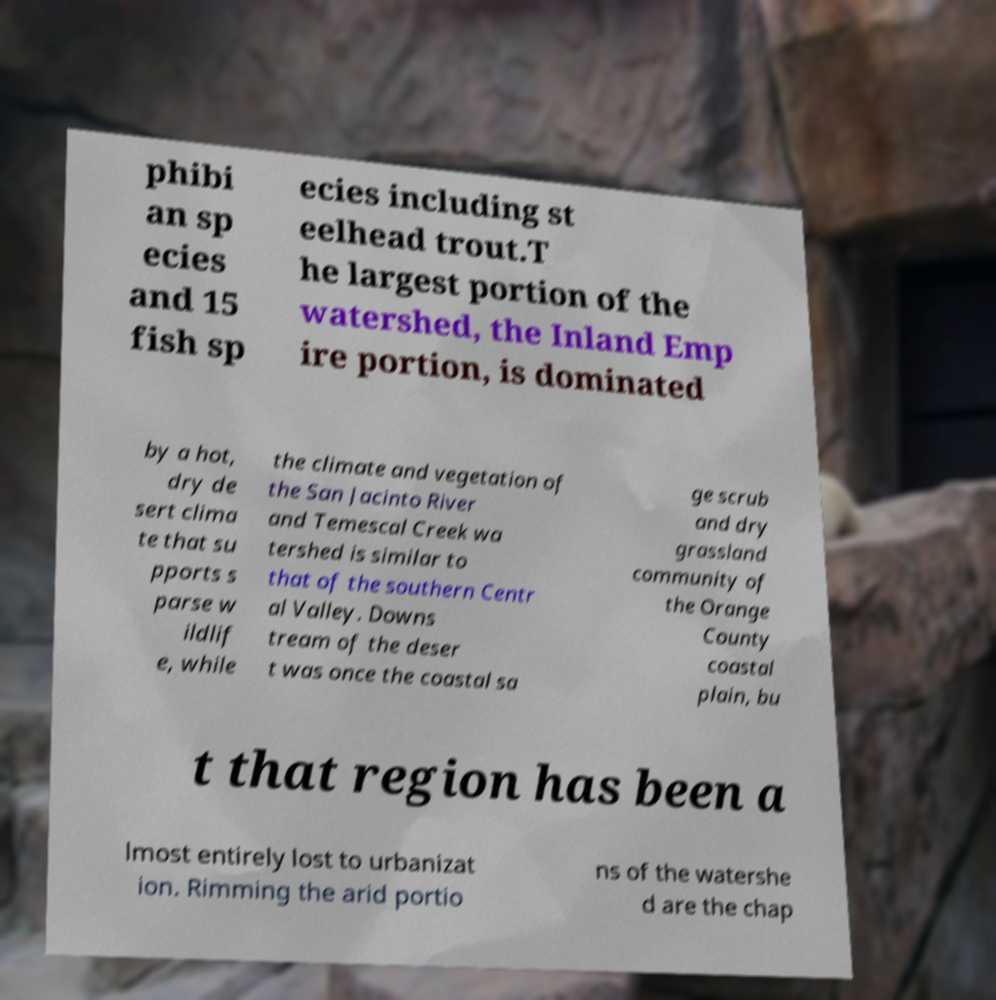Please read and relay the text visible in this image. What does it say? phibi an sp ecies and 15 fish sp ecies including st eelhead trout.T he largest portion of the watershed, the Inland Emp ire portion, is dominated by a hot, dry de sert clima te that su pports s parse w ildlif e, while the climate and vegetation of the San Jacinto River and Temescal Creek wa tershed is similar to that of the southern Centr al Valley. Downs tream of the deser t was once the coastal sa ge scrub and dry grassland community of the Orange County coastal plain, bu t that region has been a lmost entirely lost to urbanizat ion. Rimming the arid portio ns of the watershe d are the chap 